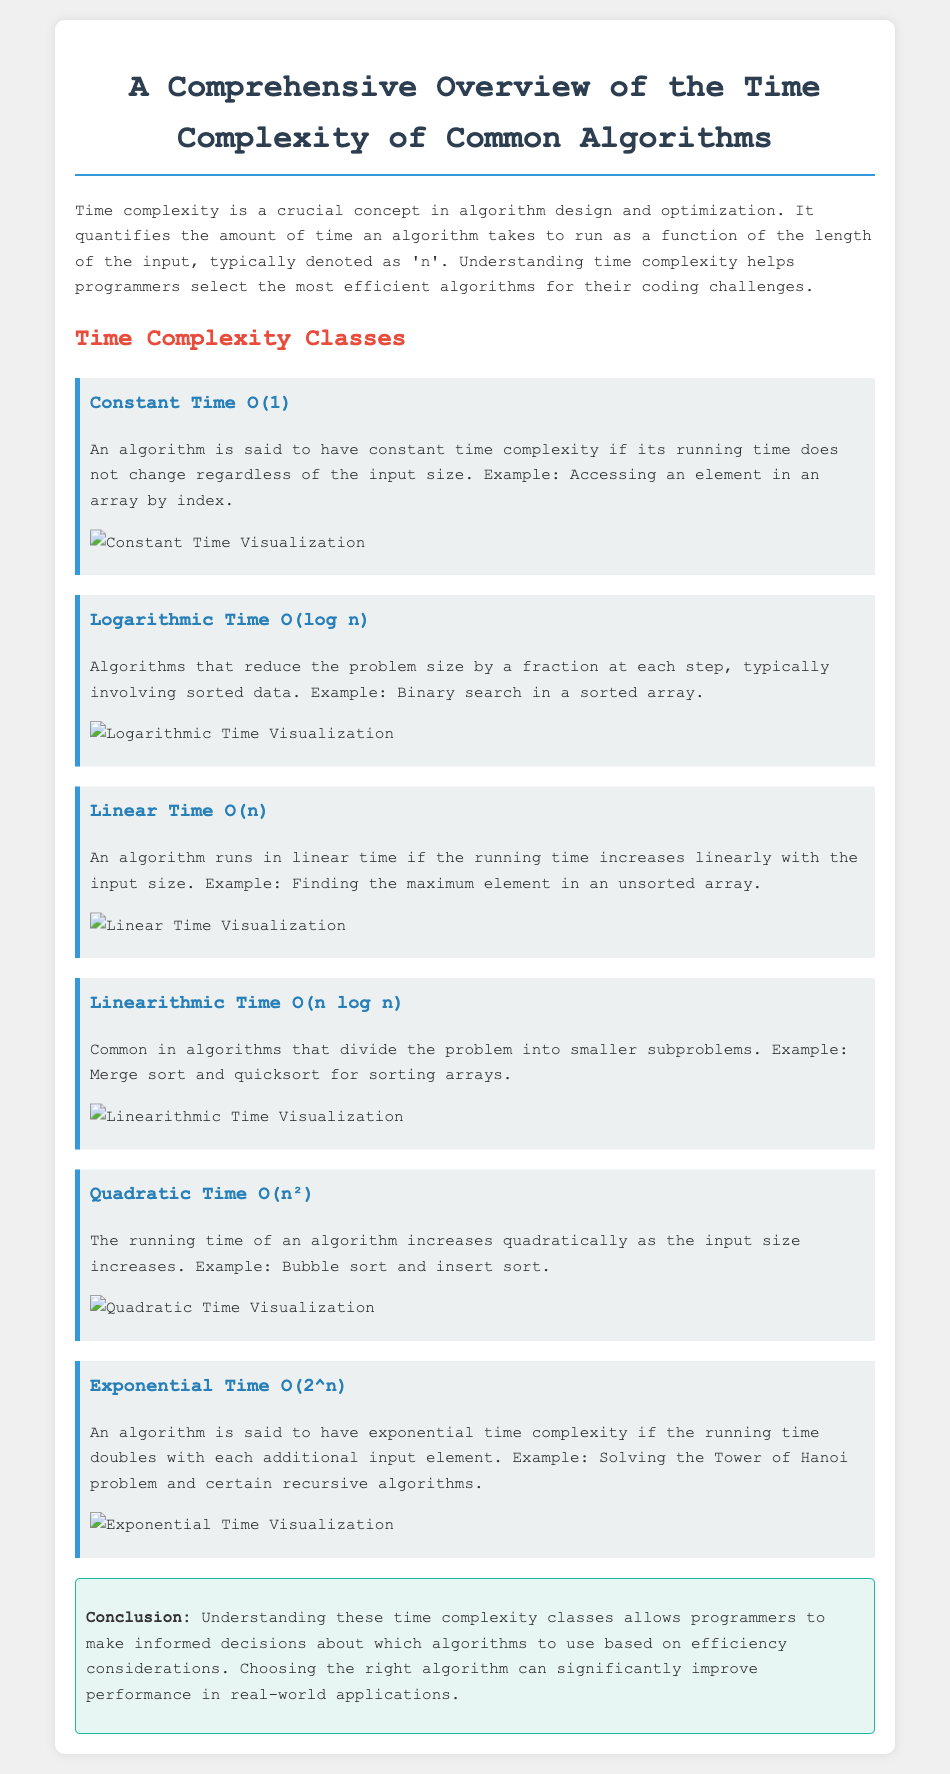What is the main concept described in the document? The document discusses the concept of time complexity, which quantifies the duration an algorithm takes to process input based on its size.
Answer: Time complexity What is the time complexity class characterized by O(1)? O(1) is defined as constant time complexity, where the running time remains unchanged regardless of input size.
Answer: Constant Time O(1) Which algorithm is an example of logarithmic time complexity? The document mentions binary search as an example of logarithmic time complexity, which works on sorted data.
Answer: Binary search How does the running time of an algorithm with quadratic time complexity increase? The running time of an algorithm with quadratic time complexity increases quadratically as the input size increases, as per the document.
Answer: Quadratically What time complexity is associated with merge sort? Merge sort is associated with linearithmic time complexity, denoted as O(n log n) in the document.
Answer: O(n log n) What is the visual representation of exponential time complexity? The document provides a specific image representing the exponential time complexity class characterized by O(2^n).
Answer: Exponential Time Visualization What is the impact of choosing the right algorithm, according to the conclusion? The conclusion indicates that selecting the appropriate algorithm can significantly enhance performance in real-world applications.
Answer: Improve performance What is an example of an algorithm with exponential time complexity? The document cites the Tower of Hanoi problem as an example of an algorithm with exponential time complexity.
Answer: Tower of Hanoi 